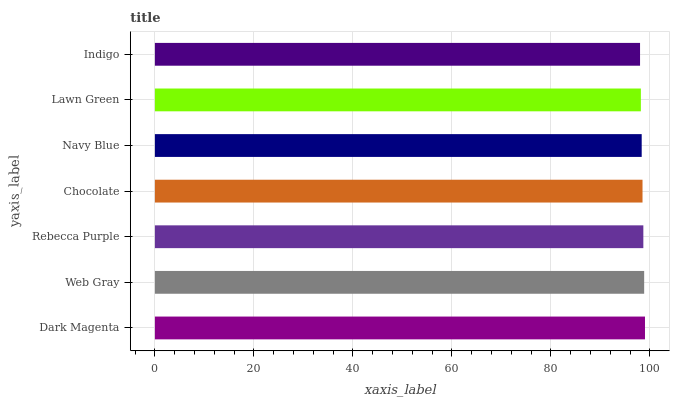Is Indigo the minimum?
Answer yes or no. Yes. Is Dark Magenta the maximum?
Answer yes or no. Yes. Is Web Gray the minimum?
Answer yes or no. No. Is Web Gray the maximum?
Answer yes or no. No. Is Dark Magenta greater than Web Gray?
Answer yes or no. Yes. Is Web Gray less than Dark Magenta?
Answer yes or no. Yes. Is Web Gray greater than Dark Magenta?
Answer yes or no. No. Is Dark Magenta less than Web Gray?
Answer yes or no. No. Is Chocolate the high median?
Answer yes or no. Yes. Is Chocolate the low median?
Answer yes or no. Yes. Is Lawn Green the high median?
Answer yes or no. No. Is Navy Blue the low median?
Answer yes or no. No. 